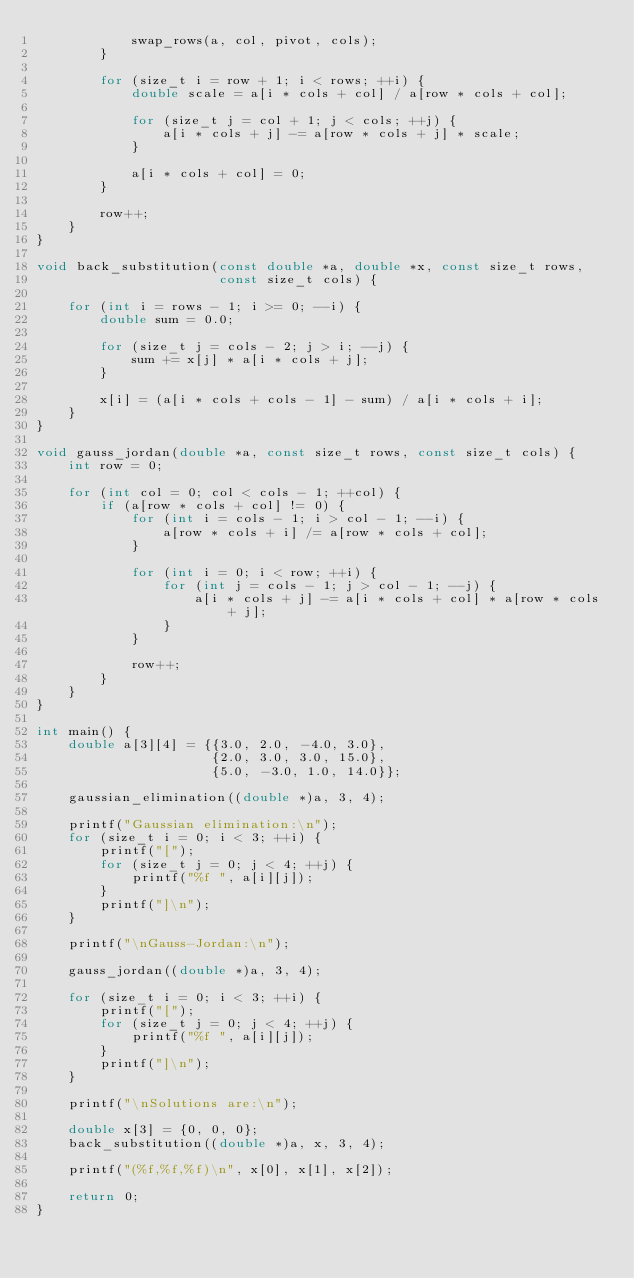Convert code to text. <code><loc_0><loc_0><loc_500><loc_500><_C_>            swap_rows(a, col, pivot, cols);
        }

        for (size_t i = row + 1; i < rows; ++i) {
            double scale = a[i * cols + col] / a[row * cols + col];

            for (size_t j = col + 1; j < cols; ++j) {
                a[i * cols + j] -= a[row * cols + j] * scale;
            }

            a[i * cols + col] = 0;
        }

        row++;
    }
}

void back_substitution(const double *a, double *x, const size_t rows,
                       const size_t cols) {

    for (int i = rows - 1; i >= 0; --i) {
        double sum = 0.0;

        for (size_t j = cols - 2; j > i; --j) {
            sum += x[j] * a[i * cols + j];
        }

        x[i] = (a[i * cols + cols - 1] - sum) / a[i * cols + i];
    }
}

void gauss_jordan(double *a, const size_t rows, const size_t cols) {
    int row = 0;

    for (int col = 0; col < cols - 1; ++col) {
        if (a[row * cols + col] != 0) {
            for (int i = cols - 1; i > col - 1; --i) {
                a[row * cols + i] /= a[row * cols + col];
            }

            for (int i = 0; i < row; ++i) {
                for (int j = cols - 1; j > col - 1; --j) {
                    a[i * cols + j] -= a[i * cols + col] * a[row * cols + j];
                }
            }

            row++;
        }
    }
}

int main() {
    double a[3][4] = {{3.0, 2.0, -4.0, 3.0},
                      {2.0, 3.0, 3.0, 15.0},
                      {5.0, -3.0, 1.0, 14.0}};

    gaussian_elimination((double *)a, 3, 4);

    printf("Gaussian elimination:\n");
    for (size_t i = 0; i < 3; ++i) {
        printf("[");
        for (size_t j = 0; j < 4; ++j) {
            printf("%f ", a[i][j]);
        }
        printf("]\n");
    }

    printf("\nGauss-Jordan:\n");

    gauss_jordan((double *)a, 3, 4);

    for (size_t i = 0; i < 3; ++i) {
        printf("[");
        for (size_t j = 0; j < 4; ++j) {
            printf("%f ", a[i][j]);
        }
        printf("]\n");
    }

    printf("\nSolutions are:\n");

    double x[3] = {0, 0, 0};
    back_substitution((double *)a, x, 3, 4);

    printf("(%f,%f,%f)\n", x[0], x[1], x[2]);

    return 0;
}
</code> 